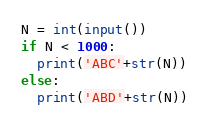<code> <loc_0><loc_0><loc_500><loc_500><_Python_>N = int(input())
if N < 1000:
  print('ABC'+str(N))
else:
  print('ABD'+str(N))</code> 